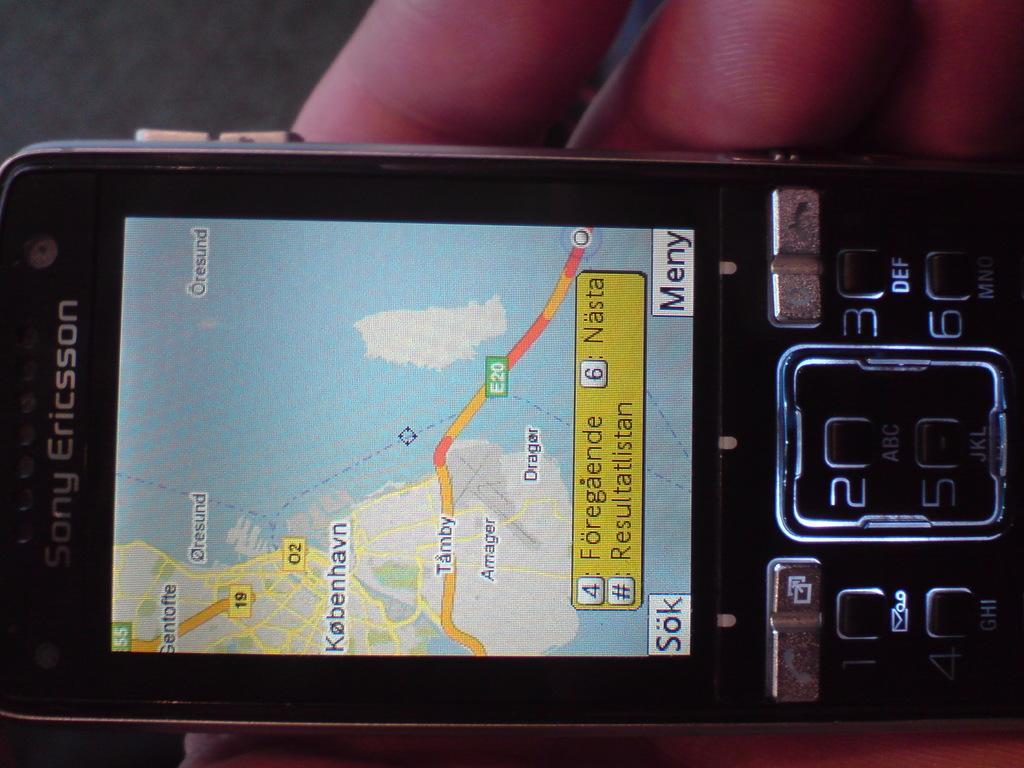<image>
Share a concise interpretation of the image provided. A Sony Ericksson device shows a map on the display. 